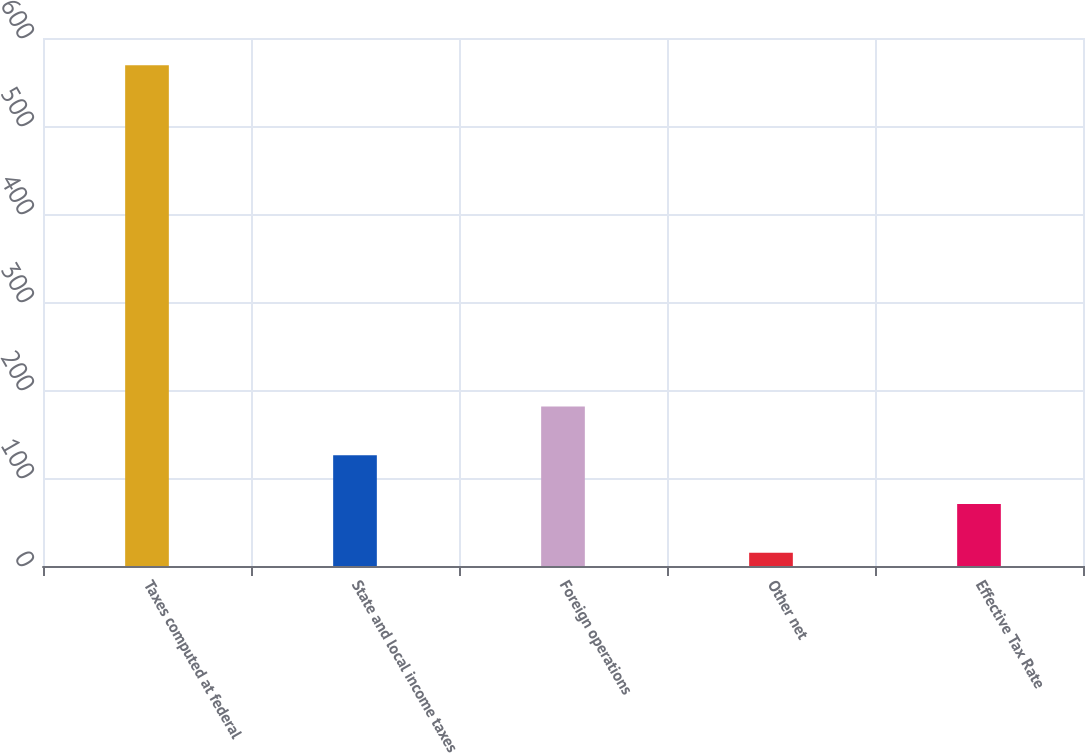Convert chart to OTSL. <chart><loc_0><loc_0><loc_500><loc_500><bar_chart><fcel>Taxes computed at federal<fcel>State and local income taxes<fcel>Foreign operations<fcel>Other net<fcel>Effective Tax Rate<nl><fcel>569<fcel>125.8<fcel>181.2<fcel>15<fcel>70.4<nl></chart> 